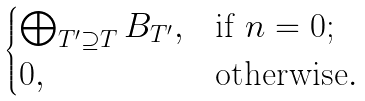<formula> <loc_0><loc_0><loc_500><loc_500>\begin{cases} \bigoplus _ { T ^ { \prime } \supseteq T } B _ { T ^ { \prime } } , & \text {if} \ n = 0 ; \\ 0 , & \text {otherwise} . \end{cases}</formula> 